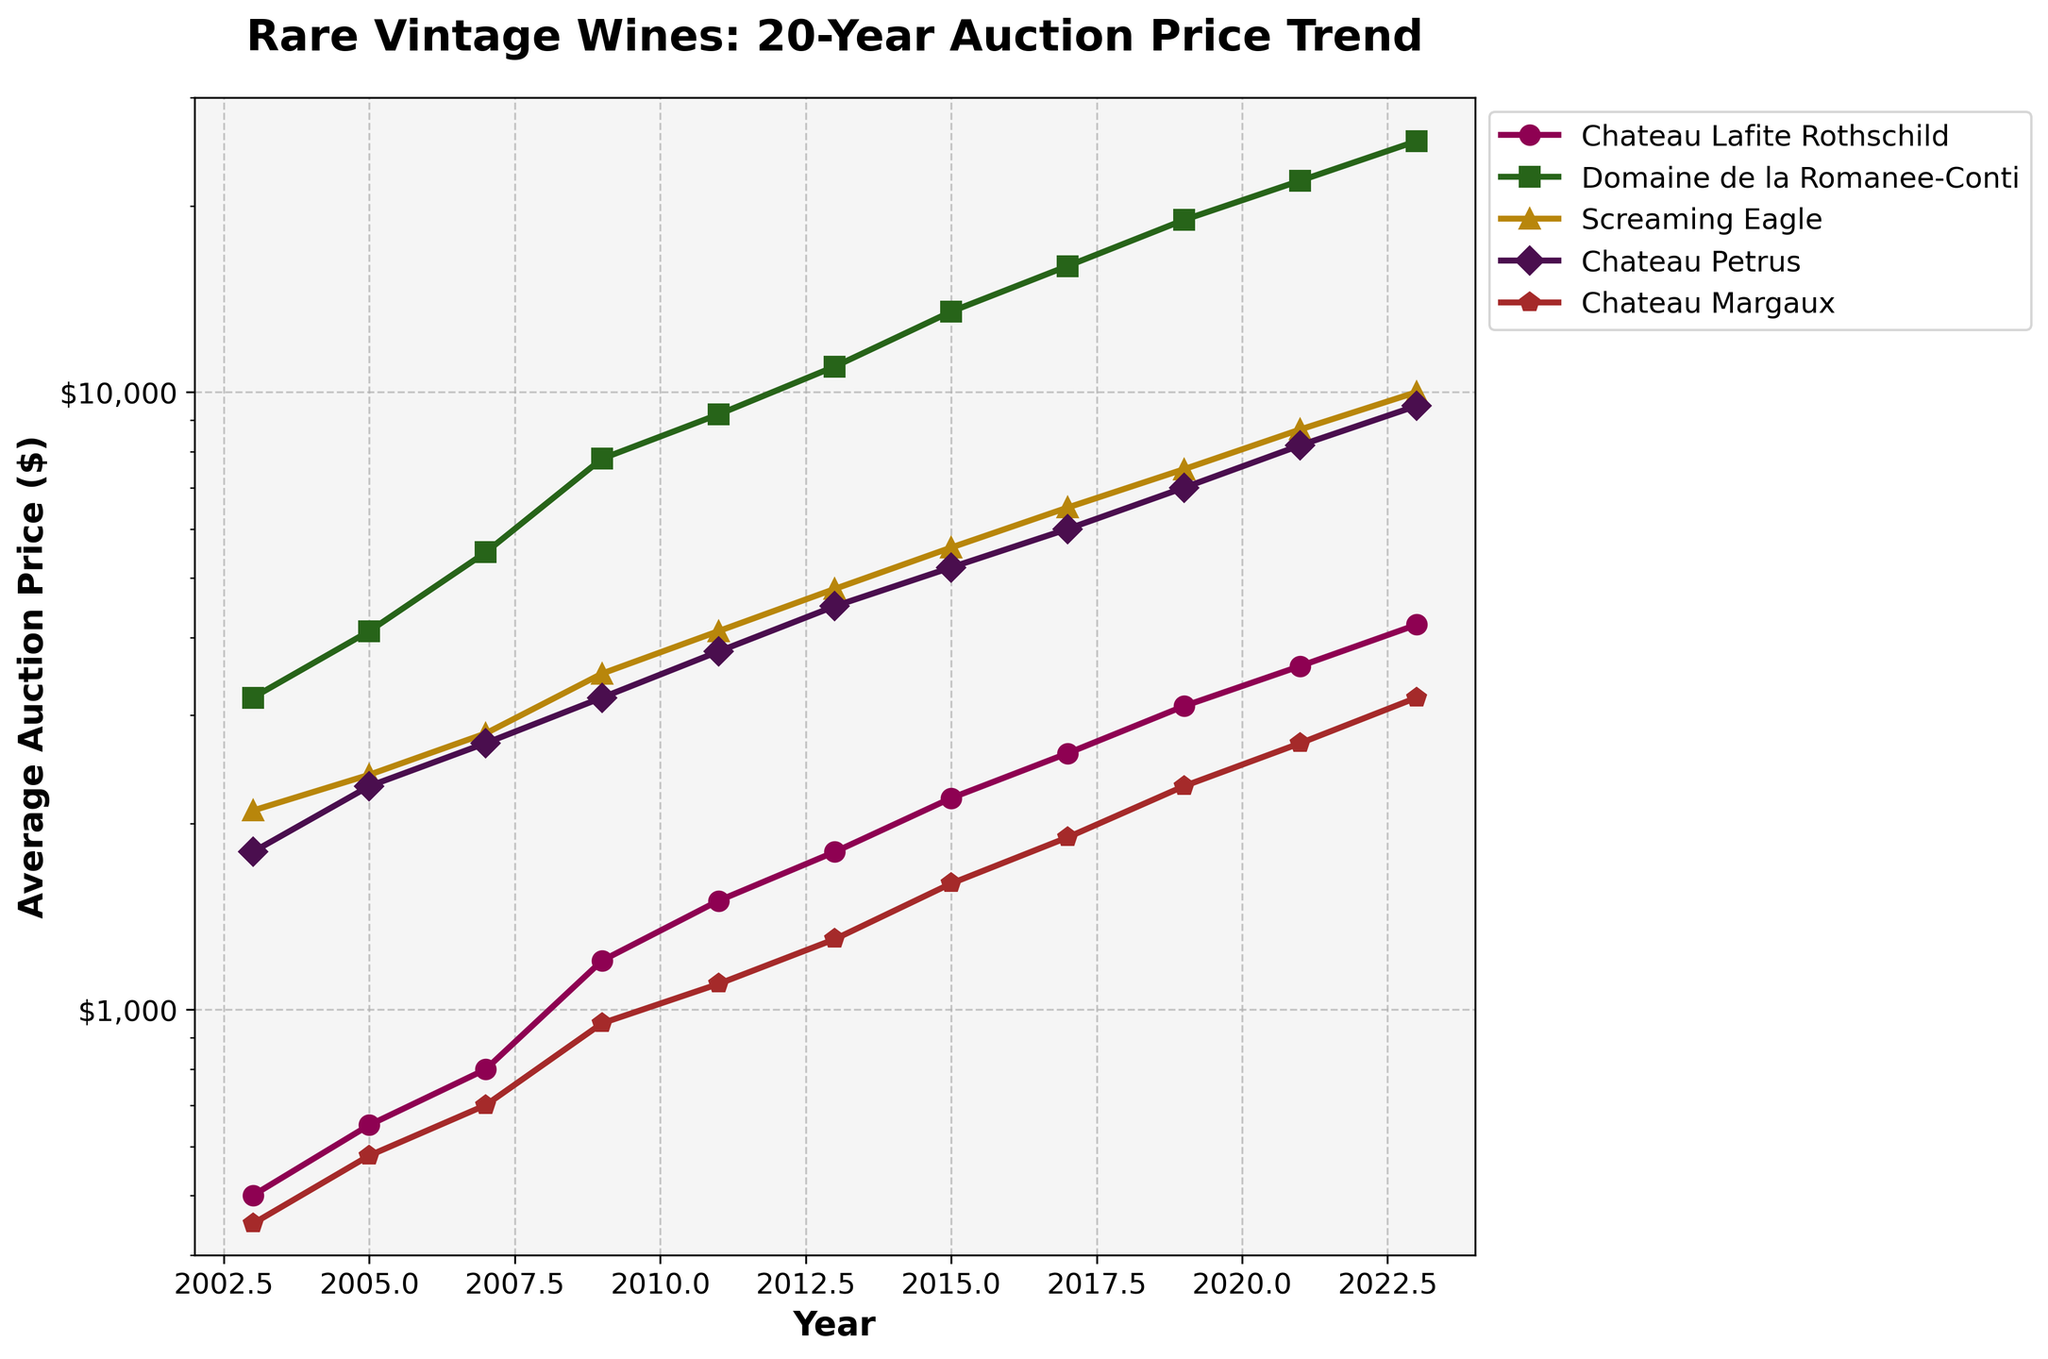Which wine had the highest average auction price in 2023? Identify the data points for 2023 and compare the prices of all wines to find the highest one. Domaine de la Romanee-Conti has the highest price at $25,500.
Answer: Domaine de la Romanee-Conti How much did the average auction price of Chateau Lafite Rothschild increase from 2003 to 2023? Subtract the 2003 value of Chateau Lafite Rothschild from the 2023 value: $4200 - $500 = $3700.
Answer: $3700 Between 2009 and 2021, which wine showed the most significant price increase? Calculate the difference in price for each wine between 2009 and 2021, then identify the highest increase. Domaine de la Romanee-Conti went from $7800 to $22,000, an increase of $14,200, the largest among the wines.
Answer: Domaine de la Romanee-Conti What was the average price of Screaming Eagle in 2017 and 2019? Add the prices of Screaming Eagle for 2017 and 2019 and divide by 2. ($6500 + $7500) / 2 = $7000.
Answer: $7000 Which wine maintained the most consistent price increase over the 20 years? Visually inspect the plots; Domaine de la Romanee-Conti appears to have a steadily increasing linear trend, with consistent upward movement.
Answer: Domaine de la Romanee-Conti In which year did Chateau Petrus first surpass a $4000 average auction price? Identify the year in the dataset when Chateau Petrus's value first exceeded $4000. It surpasses $4000 in 2015 with $5200.
Answer: 2015 How does the auction price of Chateau Margaux in 2023 compare to its price in 2011? Subtract the 2011 value of Chateau Margaux from the 2023 value: $3200 - $1100 = $2100.
Answer: $2100 increase Which wine saw the largest price increase between 2005 and 2007? Calculate the difference for each wine between 2005 and 2007. Domaine de la Romanee-Conti increased from $4100 to $5500, a difference of $1400, which is the largest.
Answer: Domaine de la Romanee-Conti Across the entire 20-year period, which wine had the least overall price volatility? Analyze the smoothness and steadiness of the lines with minimal fluctuations. Chateau Margaux shows a smoother, less volatile trend line compared to others.
Answer: Chateau Margaux What's the average annual growth rate for Domaine de la Romanee-Conti between 2003 and 2023? Calculate the compound annual growth rate (CAGR) using the formula: \(\text{CAGR} = \left( \frac{\text{Ending Value}}{\text{Beginning Value}} \right)^{\frac{1}{\text{Number of Years}}} - 1 \). For Domaine de la Romanee-Conti with an initial value of $3200 in 2003 and $25500 in 2023 over 20 years: CAGR = ((25500 / 3200)^(1/20)) - 1 ≈ 11.78%.
Answer: 11.78% 